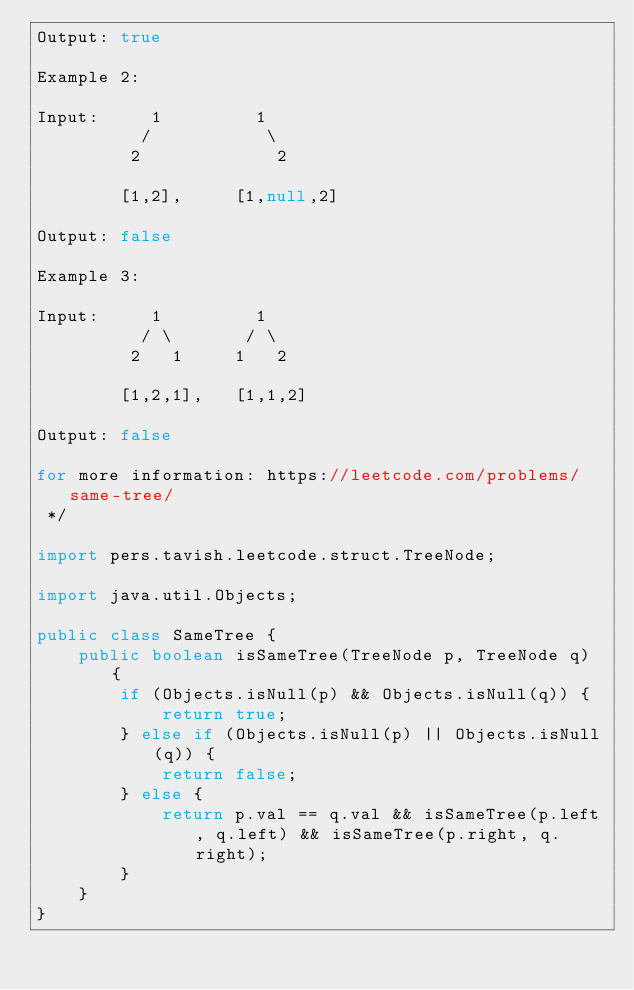Convert code to text. <code><loc_0><loc_0><loc_500><loc_500><_Java_>Output: true

Example 2:

Input:     1         1
          /           \
         2             2

        [1,2],     [1,null,2]

Output: false

Example 3:

Input:     1         1
          / \       / \
         2   1     1   2

        [1,2,1],   [1,1,2]

Output: false

for more information: https://leetcode.com/problems/same-tree/
 */

import pers.tavish.leetcode.struct.TreeNode;

import java.util.Objects;

public class SameTree {
    public boolean isSameTree(TreeNode p, TreeNode q) {
        if (Objects.isNull(p) && Objects.isNull(q)) {
            return true;
        } else if (Objects.isNull(p) || Objects.isNull(q)) {
            return false;
        } else {
            return p.val == q.val && isSameTree(p.left, q.left) && isSameTree(p.right, q.right);
        }
    }
}
</code> 